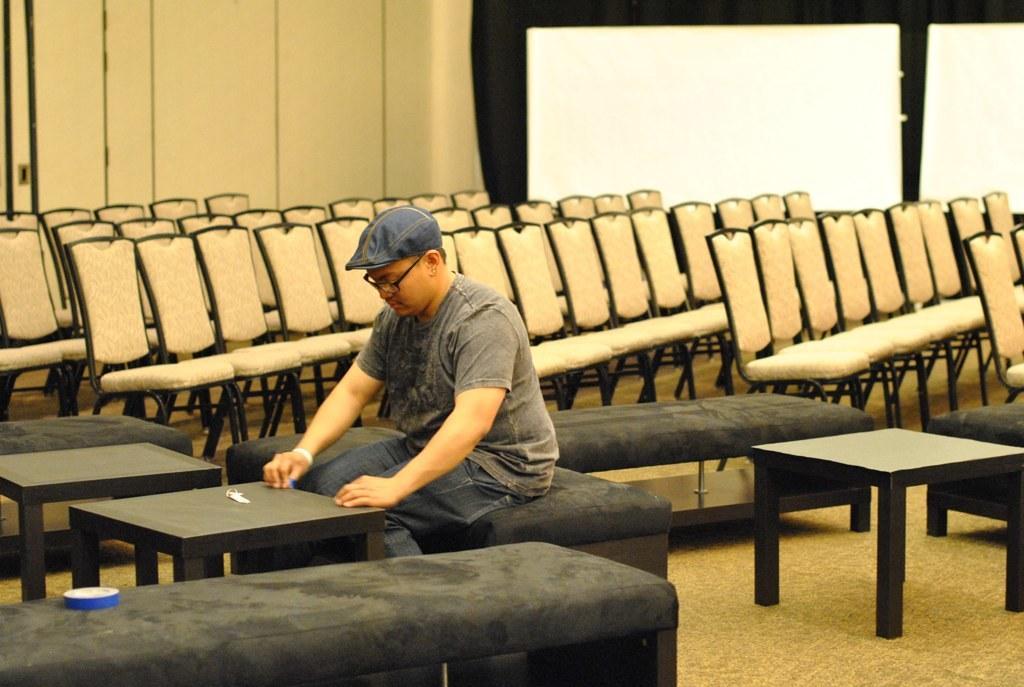Could you give a brief overview of what you see in this image? In this image there is a person sitting in a room on the bench and there are chairs in a room. 